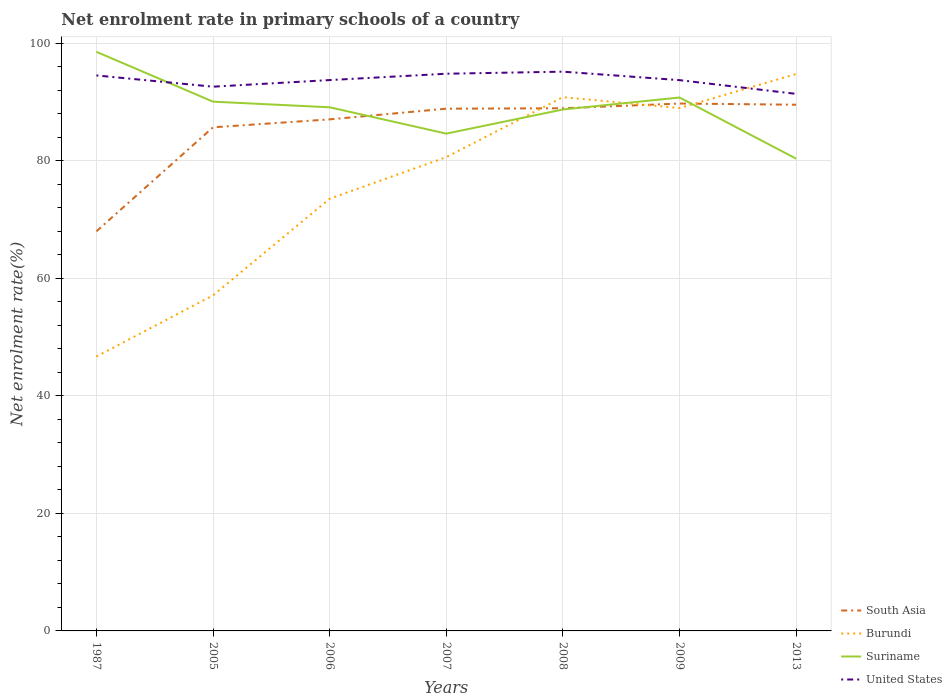Does the line corresponding to Suriname intersect with the line corresponding to Burundi?
Keep it short and to the point. Yes. Across all years, what is the maximum net enrolment rate in primary schools in South Asia?
Provide a short and direct response. 68.01. In which year was the net enrolment rate in primary schools in Burundi maximum?
Give a very brief answer. 1987. What is the total net enrolment rate in primary schools in United States in the graph?
Your answer should be very brief. -1.08. What is the difference between the highest and the second highest net enrolment rate in primary schools in South Asia?
Give a very brief answer. 21.74. What is the difference between the highest and the lowest net enrolment rate in primary schools in Suriname?
Your response must be concise. 4. Are the values on the major ticks of Y-axis written in scientific E-notation?
Your answer should be compact. No. Does the graph contain grids?
Your answer should be compact. Yes. Where does the legend appear in the graph?
Your answer should be very brief. Bottom right. How many legend labels are there?
Provide a short and direct response. 4. What is the title of the graph?
Your answer should be compact. Net enrolment rate in primary schools of a country. What is the label or title of the X-axis?
Offer a terse response. Years. What is the label or title of the Y-axis?
Provide a short and direct response. Net enrolment rate(%). What is the Net enrolment rate(%) of South Asia in 1987?
Ensure brevity in your answer.  68.01. What is the Net enrolment rate(%) in Burundi in 1987?
Provide a succinct answer. 46.7. What is the Net enrolment rate(%) in Suriname in 1987?
Offer a terse response. 98.55. What is the Net enrolment rate(%) in United States in 1987?
Offer a very short reply. 94.53. What is the Net enrolment rate(%) of South Asia in 2005?
Provide a short and direct response. 85.71. What is the Net enrolment rate(%) of Burundi in 2005?
Provide a short and direct response. 57.1. What is the Net enrolment rate(%) in Suriname in 2005?
Provide a short and direct response. 90.07. What is the Net enrolment rate(%) of United States in 2005?
Offer a very short reply. 92.62. What is the Net enrolment rate(%) of South Asia in 2006?
Offer a very short reply. 87.05. What is the Net enrolment rate(%) in Burundi in 2006?
Give a very brief answer. 73.55. What is the Net enrolment rate(%) of Suriname in 2006?
Make the answer very short. 89.11. What is the Net enrolment rate(%) of United States in 2006?
Your response must be concise. 93.74. What is the Net enrolment rate(%) of South Asia in 2007?
Offer a very short reply. 88.87. What is the Net enrolment rate(%) of Burundi in 2007?
Keep it short and to the point. 80.63. What is the Net enrolment rate(%) of Suriname in 2007?
Provide a succinct answer. 84.63. What is the Net enrolment rate(%) of United States in 2007?
Make the answer very short. 94.82. What is the Net enrolment rate(%) of South Asia in 2008?
Your answer should be very brief. 88.95. What is the Net enrolment rate(%) of Burundi in 2008?
Make the answer very short. 90.83. What is the Net enrolment rate(%) of Suriname in 2008?
Offer a very short reply. 88.74. What is the Net enrolment rate(%) in United States in 2008?
Your answer should be very brief. 95.17. What is the Net enrolment rate(%) in South Asia in 2009?
Your answer should be very brief. 89.75. What is the Net enrolment rate(%) in Burundi in 2009?
Your answer should be compact. 88.98. What is the Net enrolment rate(%) in Suriname in 2009?
Give a very brief answer. 90.78. What is the Net enrolment rate(%) in United States in 2009?
Provide a short and direct response. 93.73. What is the Net enrolment rate(%) in South Asia in 2013?
Your response must be concise. 89.55. What is the Net enrolment rate(%) in Burundi in 2013?
Offer a terse response. 94.77. What is the Net enrolment rate(%) of Suriname in 2013?
Offer a terse response. 80.36. What is the Net enrolment rate(%) in United States in 2013?
Provide a short and direct response. 91.39. Across all years, what is the maximum Net enrolment rate(%) in South Asia?
Keep it short and to the point. 89.75. Across all years, what is the maximum Net enrolment rate(%) of Burundi?
Your answer should be very brief. 94.77. Across all years, what is the maximum Net enrolment rate(%) of Suriname?
Your answer should be very brief. 98.55. Across all years, what is the maximum Net enrolment rate(%) of United States?
Give a very brief answer. 95.17. Across all years, what is the minimum Net enrolment rate(%) of South Asia?
Offer a very short reply. 68.01. Across all years, what is the minimum Net enrolment rate(%) in Burundi?
Your answer should be compact. 46.7. Across all years, what is the minimum Net enrolment rate(%) in Suriname?
Your response must be concise. 80.36. Across all years, what is the minimum Net enrolment rate(%) in United States?
Provide a succinct answer. 91.39. What is the total Net enrolment rate(%) of South Asia in the graph?
Provide a succinct answer. 597.88. What is the total Net enrolment rate(%) of Burundi in the graph?
Your answer should be compact. 532.56. What is the total Net enrolment rate(%) in Suriname in the graph?
Provide a short and direct response. 622.24. What is the total Net enrolment rate(%) of United States in the graph?
Your answer should be very brief. 656.01. What is the difference between the Net enrolment rate(%) in South Asia in 1987 and that in 2005?
Provide a succinct answer. -17.7. What is the difference between the Net enrolment rate(%) of Burundi in 1987 and that in 2005?
Your answer should be very brief. -10.4. What is the difference between the Net enrolment rate(%) of Suriname in 1987 and that in 2005?
Keep it short and to the point. 8.48. What is the difference between the Net enrolment rate(%) in United States in 1987 and that in 2005?
Ensure brevity in your answer.  1.91. What is the difference between the Net enrolment rate(%) in South Asia in 1987 and that in 2006?
Ensure brevity in your answer.  -19.05. What is the difference between the Net enrolment rate(%) in Burundi in 1987 and that in 2006?
Your answer should be compact. -26.85. What is the difference between the Net enrolment rate(%) of Suriname in 1987 and that in 2006?
Make the answer very short. 9.44. What is the difference between the Net enrolment rate(%) of United States in 1987 and that in 2006?
Give a very brief answer. 0.79. What is the difference between the Net enrolment rate(%) of South Asia in 1987 and that in 2007?
Provide a succinct answer. -20.87. What is the difference between the Net enrolment rate(%) in Burundi in 1987 and that in 2007?
Your response must be concise. -33.93. What is the difference between the Net enrolment rate(%) in Suriname in 1987 and that in 2007?
Provide a short and direct response. 13.92. What is the difference between the Net enrolment rate(%) of United States in 1987 and that in 2007?
Provide a succinct answer. -0.29. What is the difference between the Net enrolment rate(%) of South Asia in 1987 and that in 2008?
Offer a very short reply. -20.94. What is the difference between the Net enrolment rate(%) of Burundi in 1987 and that in 2008?
Your answer should be very brief. -44.13. What is the difference between the Net enrolment rate(%) of Suriname in 1987 and that in 2008?
Offer a very short reply. 9.82. What is the difference between the Net enrolment rate(%) in United States in 1987 and that in 2008?
Offer a terse response. -0.64. What is the difference between the Net enrolment rate(%) of South Asia in 1987 and that in 2009?
Offer a very short reply. -21.74. What is the difference between the Net enrolment rate(%) of Burundi in 1987 and that in 2009?
Keep it short and to the point. -42.28. What is the difference between the Net enrolment rate(%) in Suriname in 1987 and that in 2009?
Make the answer very short. 7.78. What is the difference between the Net enrolment rate(%) of United States in 1987 and that in 2009?
Your answer should be very brief. 0.8. What is the difference between the Net enrolment rate(%) in South Asia in 1987 and that in 2013?
Provide a succinct answer. -21.54. What is the difference between the Net enrolment rate(%) in Burundi in 1987 and that in 2013?
Provide a short and direct response. -48.08. What is the difference between the Net enrolment rate(%) in Suriname in 1987 and that in 2013?
Offer a terse response. 18.19. What is the difference between the Net enrolment rate(%) of United States in 1987 and that in 2013?
Offer a very short reply. 3.14. What is the difference between the Net enrolment rate(%) in South Asia in 2005 and that in 2006?
Keep it short and to the point. -1.35. What is the difference between the Net enrolment rate(%) of Burundi in 2005 and that in 2006?
Keep it short and to the point. -16.45. What is the difference between the Net enrolment rate(%) of Suriname in 2005 and that in 2006?
Offer a terse response. 0.96. What is the difference between the Net enrolment rate(%) in United States in 2005 and that in 2006?
Your response must be concise. -1.13. What is the difference between the Net enrolment rate(%) in South Asia in 2005 and that in 2007?
Provide a succinct answer. -3.17. What is the difference between the Net enrolment rate(%) in Burundi in 2005 and that in 2007?
Your answer should be very brief. -23.53. What is the difference between the Net enrolment rate(%) of Suriname in 2005 and that in 2007?
Provide a short and direct response. 5.44. What is the difference between the Net enrolment rate(%) of United States in 2005 and that in 2007?
Give a very brief answer. -2.21. What is the difference between the Net enrolment rate(%) in South Asia in 2005 and that in 2008?
Provide a succinct answer. -3.24. What is the difference between the Net enrolment rate(%) in Burundi in 2005 and that in 2008?
Your answer should be compact. -33.73. What is the difference between the Net enrolment rate(%) of Suriname in 2005 and that in 2008?
Keep it short and to the point. 1.33. What is the difference between the Net enrolment rate(%) of United States in 2005 and that in 2008?
Offer a terse response. -2.55. What is the difference between the Net enrolment rate(%) in South Asia in 2005 and that in 2009?
Offer a very short reply. -4.04. What is the difference between the Net enrolment rate(%) in Burundi in 2005 and that in 2009?
Offer a terse response. -31.87. What is the difference between the Net enrolment rate(%) of Suriname in 2005 and that in 2009?
Your response must be concise. -0.71. What is the difference between the Net enrolment rate(%) in United States in 2005 and that in 2009?
Provide a short and direct response. -1.11. What is the difference between the Net enrolment rate(%) in South Asia in 2005 and that in 2013?
Give a very brief answer. -3.84. What is the difference between the Net enrolment rate(%) in Burundi in 2005 and that in 2013?
Your answer should be very brief. -37.67. What is the difference between the Net enrolment rate(%) of Suriname in 2005 and that in 2013?
Give a very brief answer. 9.71. What is the difference between the Net enrolment rate(%) of United States in 2005 and that in 2013?
Offer a terse response. 1.23. What is the difference between the Net enrolment rate(%) in South Asia in 2006 and that in 2007?
Ensure brevity in your answer.  -1.82. What is the difference between the Net enrolment rate(%) in Burundi in 2006 and that in 2007?
Give a very brief answer. -7.08. What is the difference between the Net enrolment rate(%) in Suriname in 2006 and that in 2007?
Provide a short and direct response. 4.48. What is the difference between the Net enrolment rate(%) in United States in 2006 and that in 2007?
Provide a succinct answer. -1.08. What is the difference between the Net enrolment rate(%) in South Asia in 2006 and that in 2008?
Your answer should be very brief. -1.89. What is the difference between the Net enrolment rate(%) of Burundi in 2006 and that in 2008?
Give a very brief answer. -17.28. What is the difference between the Net enrolment rate(%) of Suriname in 2006 and that in 2008?
Make the answer very short. 0.37. What is the difference between the Net enrolment rate(%) in United States in 2006 and that in 2008?
Make the answer very short. -1.43. What is the difference between the Net enrolment rate(%) of South Asia in 2006 and that in 2009?
Keep it short and to the point. -2.7. What is the difference between the Net enrolment rate(%) of Burundi in 2006 and that in 2009?
Your response must be concise. -15.43. What is the difference between the Net enrolment rate(%) in Suriname in 2006 and that in 2009?
Your response must be concise. -1.67. What is the difference between the Net enrolment rate(%) of United States in 2006 and that in 2009?
Ensure brevity in your answer.  0.01. What is the difference between the Net enrolment rate(%) in South Asia in 2006 and that in 2013?
Make the answer very short. -2.49. What is the difference between the Net enrolment rate(%) in Burundi in 2006 and that in 2013?
Ensure brevity in your answer.  -21.22. What is the difference between the Net enrolment rate(%) of Suriname in 2006 and that in 2013?
Offer a very short reply. 8.75. What is the difference between the Net enrolment rate(%) of United States in 2006 and that in 2013?
Offer a very short reply. 2.35. What is the difference between the Net enrolment rate(%) in South Asia in 2007 and that in 2008?
Provide a short and direct response. -0.07. What is the difference between the Net enrolment rate(%) in Burundi in 2007 and that in 2008?
Ensure brevity in your answer.  -10.2. What is the difference between the Net enrolment rate(%) of Suriname in 2007 and that in 2008?
Ensure brevity in your answer.  -4.11. What is the difference between the Net enrolment rate(%) of United States in 2007 and that in 2008?
Provide a short and direct response. -0.35. What is the difference between the Net enrolment rate(%) of South Asia in 2007 and that in 2009?
Make the answer very short. -0.88. What is the difference between the Net enrolment rate(%) in Burundi in 2007 and that in 2009?
Offer a terse response. -8.35. What is the difference between the Net enrolment rate(%) of Suriname in 2007 and that in 2009?
Offer a very short reply. -6.15. What is the difference between the Net enrolment rate(%) of United States in 2007 and that in 2009?
Keep it short and to the point. 1.09. What is the difference between the Net enrolment rate(%) in South Asia in 2007 and that in 2013?
Keep it short and to the point. -0.68. What is the difference between the Net enrolment rate(%) of Burundi in 2007 and that in 2013?
Your answer should be compact. -14.15. What is the difference between the Net enrolment rate(%) in Suriname in 2007 and that in 2013?
Offer a very short reply. 4.27. What is the difference between the Net enrolment rate(%) in United States in 2007 and that in 2013?
Your answer should be compact. 3.43. What is the difference between the Net enrolment rate(%) in South Asia in 2008 and that in 2009?
Your answer should be very brief. -0.8. What is the difference between the Net enrolment rate(%) in Burundi in 2008 and that in 2009?
Offer a terse response. 1.85. What is the difference between the Net enrolment rate(%) in Suriname in 2008 and that in 2009?
Your answer should be very brief. -2.04. What is the difference between the Net enrolment rate(%) in United States in 2008 and that in 2009?
Offer a terse response. 1.44. What is the difference between the Net enrolment rate(%) of South Asia in 2008 and that in 2013?
Make the answer very short. -0.6. What is the difference between the Net enrolment rate(%) in Burundi in 2008 and that in 2013?
Offer a terse response. -3.94. What is the difference between the Net enrolment rate(%) of Suriname in 2008 and that in 2013?
Provide a short and direct response. 8.38. What is the difference between the Net enrolment rate(%) of United States in 2008 and that in 2013?
Offer a very short reply. 3.78. What is the difference between the Net enrolment rate(%) in South Asia in 2009 and that in 2013?
Keep it short and to the point. 0.2. What is the difference between the Net enrolment rate(%) of Burundi in 2009 and that in 2013?
Give a very brief answer. -5.8. What is the difference between the Net enrolment rate(%) in Suriname in 2009 and that in 2013?
Your answer should be very brief. 10.42. What is the difference between the Net enrolment rate(%) of United States in 2009 and that in 2013?
Give a very brief answer. 2.34. What is the difference between the Net enrolment rate(%) of South Asia in 1987 and the Net enrolment rate(%) of Burundi in 2005?
Your answer should be very brief. 10.9. What is the difference between the Net enrolment rate(%) in South Asia in 1987 and the Net enrolment rate(%) in Suriname in 2005?
Give a very brief answer. -22.07. What is the difference between the Net enrolment rate(%) in South Asia in 1987 and the Net enrolment rate(%) in United States in 2005?
Your answer should be very brief. -24.61. What is the difference between the Net enrolment rate(%) in Burundi in 1987 and the Net enrolment rate(%) in Suriname in 2005?
Ensure brevity in your answer.  -43.37. What is the difference between the Net enrolment rate(%) of Burundi in 1987 and the Net enrolment rate(%) of United States in 2005?
Offer a very short reply. -45.92. What is the difference between the Net enrolment rate(%) in Suriname in 1987 and the Net enrolment rate(%) in United States in 2005?
Ensure brevity in your answer.  5.93. What is the difference between the Net enrolment rate(%) in South Asia in 1987 and the Net enrolment rate(%) in Burundi in 2006?
Give a very brief answer. -5.54. What is the difference between the Net enrolment rate(%) in South Asia in 1987 and the Net enrolment rate(%) in Suriname in 2006?
Provide a succinct answer. -21.1. What is the difference between the Net enrolment rate(%) of South Asia in 1987 and the Net enrolment rate(%) of United States in 2006?
Your answer should be compact. -25.74. What is the difference between the Net enrolment rate(%) in Burundi in 1987 and the Net enrolment rate(%) in Suriname in 2006?
Your response must be concise. -42.41. What is the difference between the Net enrolment rate(%) in Burundi in 1987 and the Net enrolment rate(%) in United States in 2006?
Offer a very short reply. -47.04. What is the difference between the Net enrolment rate(%) of Suriname in 1987 and the Net enrolment rate(%) of United States in 2006?
Keep it short and to the point. 4.81. What is the difference between the Net enrolment rate(%) of South Asia in 1987 and the Net enrolment rate(%) of Burundi in 2007?
Make the answer very short. -12.62. What is the difference between the Net enrolment rate(%) in South Asia in 1987 and the Net enrolment rate(%) in Suriname in 2007?
Your response must be concise. -16.63. What is the difference between the Net enrolment rate(%) of South Asia in 1987 and the Net enrolment rate(%) of United States in 2007?
Offer a terse response. -26.82. What is the difference between the Net enrolment rate(%) of Burundi in 1987 and the Net enrolment rate(%) of Suriname in 2007?
Your answer should be very brief. -37.93. What is the difference between the Net enrolment rate(%) of Burundi in 1987 and the Net enrolment rate(%) of United States in 2007?
Your response must be concise. -48.12. What is the difference between the Net enrolment rate(%) in Suriname in 1987 and the Net enrolment rate(%) in United States in 2007?
Offer a terse response. 3.73. What is the difference between the Net enrolment rate(%) in South Asia in 1987 and the Net enrolment rate(%) in Burundi in 2008?
Offer a terse response. -22.83. What is the difference between the Net enrolment rate(%) of South Asia in 1987 and the Net enrolment rate(%) of Suriname in 2008?
Make the answer very short. -20.73. What is the difference between the Net enrolment rate(%) of South Asia in 1987 and the Net enrolment rate(%) of United States in 2008?
Offer a terse response. -27.17. What is the difference between the Net enrolment rate(%) of Burundi in 1987 and the Net enrolment rate(%) of Suriname in 2008?
Provide a short and direct response. -42.04. What is the difference between the Net enrolment rate(%) of Burundi in 1987 and the Net enrolment rate(%) of United States in 2008?
Give a very brief answer. -48.47. What is the difference between the Net enrolment rate(%) of Suriname in 1987 and the Net enrolment rate(%) of United States in 2008?
Offer a very short reply. 3.38. What is the difference between the Net enrolment rate(%) of South Asia in 1987 and the Net enrolment rate(%) of Burundi in 2009?
Your answer should be compact. -20.97. What is the difference between the Net enrolment rate(%) in South Asia in 1987 and the Net enrolment rate(%) in Suriname in 2009?
Give a very brief answer. -22.77. What is the difference between the Net enrolment rate(%) of South Asia in 1987 and the Net enrolment rate(%) of United States in 2009?
Your response must be concise. -25.73. What is the difference between the Net enrolment rate(%) of Burundi in 1987 and the Net enrolment rate(%) of Suriname in 2009?
Your answer should be very brief. -44.08. What is the difference between the Net enrolment rate(%) of Burundi in 1987 and the Net enrolment rate(%) of United States in 2009?
Offer a very short reply. -47.03. What is the difference between the Net enrolment rate(%) of Suriname in 1987 and the Net enrolment rate(%) of United States in 2009?
Your response must be concise. 4.82. What is the difference between the Net enrolment rate(%) of South Asia in 1987 and the Net enrolment rate(%) of Burundi in 2013?
Provide a short and direct response. -26.77. What is the difference between the Net enrolment rate(%) of South Asia in 1987 and the Net enrolment rate(%) of Suriname in 2013?
Your response must be concise. -12.36. What is the difference between the Net enrolment rate(%) in South Asia in 1987 and the Net enrolment rate(%) in United States in 2013?
Provide a short and direct response. -23.39. What is the difference between the Net enrolment rate(%) of Burundi in 1987 and the Net enrolment rate(%) of Suriname in 2013?
Offer a terse response. -33.66. What is the difference between the Net enrolment rate(%) in Burundi in 1987 and the Net enrolment rate(%) in United States in 2013?
Your answer should be compact. -44.69. What is the difference between the Net enrolment rate(%) in Suriname in 1987 and the Net enrolment rate(%) in United States in 2013?
Ensure brevity in your answer.  7.16. What is the difference between the Net enrolment rate(%) in South Asia in 2005 and the Net enrolment rate(%) in Burundi in 2006?
Your answer should be compact. 12.16. What is the difference between the Net enrolment rate(%) of South Asia in 2005 and the Net enrolment rate(%) of Suriname in 2006?
Keep it short and to the point. -3.4. What is the difference between the Net enrolment rate(%) in South Asia in 2005 and the Net enrolment rate(%) in United States in 2006?
Offer a terse response. -8.04. What is the difference between the Net enrolment rate(%) in Burundi in 2005 and the Net enrolment rate(%) in Suriname in 2006?
Your response must be concise. -32.01. What is the difference between the Net enrolment rate(%) of Burundi in 2005 and the Net enrolment rate(%) of United States in 2006?
Your answer should be very brief. -36.64. What is the difference between the Net enrolment rate(%) of Suriname in 2005 and the Net enrolment rate(%) of United States in 2006?
Keep it short and to the point. -3.67. What is the difference between the Net enrolment rate(%) in South Asia in 2005 and the Net enrolment rate(%) in Burundi in 2007?
Keep it short and to the point. 5.08. What is the difference between the Net enrolment rate(%) in South Asia in 2005 and the Net enrolment rate(%) in Suriname in 2007?
Give a very brief answer. 1.07. What is the difference between the Net enrolment rate(%) in South Asia in 2005 and the Net enrolment rate(%) in United States in 2007?
Offer a terse response. -9.12. What is the difference between the Net enrolment rate(%) of Burundi in 2005 and the Net enrolment rate(%) of Suriname in 2007?
Make the answer very short. -27.53. What is the difference between the Net enrolment rate(%) in Burundi in 2005 and the Net enrolment rate(%) in United States in 2007?
Provide a succinct answer. -37.72. What is the difference between the Net enrolment rate(%) of Suriname in 2005 and the Net enrolment rate(%) of United States in 2007?
Your response must be concise. -4.75. What is the difference between the Net enrolment rate(%) in South Asia in 2005 and the Net enrolment rate(%) in Burundi in 2008?
Give a very brief answer. -5.13. What is the difference between the Net enrolment rate(%) of South Asia in 2005 and the Net enrolment rate(%) of Suriname in 2008?
Your response must be concise. -3.03. What is the difference between the Net enrolment rate(%) of South Asia in 2005 and the Net enrolment rate(%) of United States in 2008?
Your answer should be compact. -9.47. What is the difference between the Net enrolment rate(%) of Burundi in 2005 and the Net enrolment rate(%) of Suriname in 2008?
Give a very brief answer. -31.63. What is the difference between the Net enrolment rate(%) of Burundi in 2005 and the Net enrolment rate(%) of United States in 2008?
Offer a terse response. -38.07. What is the difference between the Net enrolment rate(%) of Suriname in 2005 and the Net enrolment rate(%) of United States in 2008?
Offer a very short reply. -5.1. What is the difference between the Net enrolment rate(%) of South Asia in 2005 and the Net enrolment rate(%) of Burundi in 2009?
Your response must be concise. -3.27. What is the difference between the Net enrolment rate(%) of South Asia in 2005 and the Net enrolment rate(%) of Suriname in 2009?
Make the answer very short. -5.07. What is the difference between the Net enrolment rate(%) in South Asia in 2005 and the Net enrolment rate(%) in United States in 2009?
Provide a succinct answer. -8.03. What is the difference between the Net enrolment rate(%) of Burundi in 2005 and the Net enrolment rate(%) of Suriname in 2009?
Keep it short and to the point. -33.67. What is the difference between the Net enrolment rate(%) of Burundi in 2005 and the Net enrolment rate(%) of United States in 2009?
Your answer should be very brief. -36.63. What is the difference between the Net enrolment rate(%) of Suriname in 2005 and the Net enrolment rate(%) of United States in 2009?
Your answer should be very brief. -3.66. What is the difference between the Net enrolment rate(%) of South Asia in 2005 and the Net enrolment rate(%) of Burundi in 2013?
Offer a terse response. -9.07. What is the difference between the Net enrolment rate(%) in South Asia in 2005 and the Net enrolment rate(%) in Suriname in 2013?
Offer a very short reply. 5.34. What is the difference between the Net enrolment rate(%) in South Asia in 2005 and the Net enrolment rate(%) in United States in 2013?
Your response must be concise. -5.69. What is the difference between the Net enrolment rate(%) in Burundi in 2005 and the Net enrolment rate(%) in Suriname in 2013?
Provide a short and direct response. -23.26. What is the difference between the Net enrolment rate(%) of Burundi in 2005 and the Net enrolment rate(%) of United States in 2013?
Give a very brief answer. -34.29. What is the difference between the Net enrolment rate(%) in Suriname in 2005 and the Net enrolment rate(%) in United States in 2013?
Make the answer very short. -1.32. What is the difference between the Net enrolment rate(%) in South Asia in 2006 and the Net enrolment rate(%) in Burundi in 2007?
Ensure brevity in your answer.  6.43. What is the difference between the Net enrolment rate(%) in South Asia in 2006 and the Net enrolment rate(%) in Suriname in 2007?
Your answer should be compact. 2.42. What is the difference between the Net enrolment rate(%) in South Asia in 2006 and the Net enrolment rate(%) in United States in 2007?
Provide a short and direct response. -7.77. What is the difference between the Net enrolment rate(%) of Burundi in 2006 and the Net enrolment rate(%) of Suriname in 2007?
Your answer should be very brief. -11.08. What is the difference between the Net enrolment rate(%) of Burundi in 2006 and the Net enrolment rate(%) of United States in 2007?
Provide a short and direct response. -21.27. What is the difference between the Net enrolment rate(%) of Suriname in 2006 and the Net enrolment rate(%) of United States in 2007?
Provide a short and direct response. -5.71. What is the difference between the Net enrolment rate(%) in South Asia in 2006 and the Net enrolment rate(%) in Burundi in 2008?
Offer a very short reply. -3.78. What is the difference between the Net enrolment rate(%) of South Asia in 2006 and the Net enrolment rate(%) of Suriname in 2008?
Offer a very short reply. -1.68. What is the difference between the Net enrolment rate(%) of South Asia in 2006 and the Net enrolment rate(%) of United States in 2008?
Provide a short and direct response. -8.12. What is the difference between the Net enrolment rate(%) of Burundi in 2006 and the Net enrolment rate(%) of Suriname in 2008?
Offer a terse response. -15.19. What is the difference between the Net enrolment rate(%) in Burundi in 2006 and the Net enrolment rate(%) in United States in 2008?
Make the answer very short. -21.62. What is the difference between the Net enrolment rate(%) of Suriname in 2006 and the Net enrolment rate(%) of United States in 2008?
Offer a very short reply. -6.06. What is the difference between the Net enrolment rate(%) of South Asia in 2006 and the Net enrolment rate(%) of Burundi in 2009?
Your answer should be compact. -1.92. What is the difference between the Net enrolment rate(%) of South Asia in 2006 and the Net enrolment rate(%) of Suriname in 2009?
Your answer should be very brief. -3.72. What is the difference between the Net enrolment rate(%) in South Asia in 2006 and the Net enrolment rate(%) in United States in 2009?
Keep it short and to the point. -6.68. What is the difference between the Net enrolment rate(%) in Burundi in 2006 and the Net enrolment rate(%) in Suriname in 2009?
Provide a succinct answer. -17.23. What is the difference between the Net enrolment rate(%) of Burundi in 2006 and the Net enrolment rate(%) of United States in 2009?
Keep it short and to the point. -20.18. What is the difference between the Net enrolment rate(%) in Suriname in 2006 and the Net enrolment rate(%) in United States in 2009?
Give a very brief answer. -4.62. What is the difference between the Net enrolment rate(%) in South Asia in 2006 and the Net enrolment rate(%) in Burundi in 2013?
Ensure brevity in your answer.  -7.72. What is the difference between the Net enrolment rate(%) in South Asia in 2006 and the Net enrolment rate(%) in Suriname in 2013?
Your answer should be compact. 6.69. What is the difference between the Net enrolment rate(%) in South Asia in 2006 and the Net enrolment rate(%) in United States in 2013?
Offer a terse response. -4.34. What is the difference between the Net enrolment rate(%) of Burundi in 2006 and the Net enrolment rate(%) of Suriname in 2013?
Offer a very short reply. -6.81. What is the difference between the Net enrolment rate(%) of Burundi in 2006 and the Net enrolment rate(%) of United States in 2013?
Your response must be concise. -17.84. What is the difference between the Net enrolment rate(%) of Suriname in 2006 and the Net enrolment rate(%) of United States in 2013?
Keep it short and to the point. -2.28. What is the difference between the Net enrolment rate(%) in South Asia in 2007 and the Net enrolment rate(%) in Burundi in 2008?
Your answer should be very brief. -1.96. What is the difference between the Net enrolment rate(%) in South Asia in 2007 and the Net enrolment rate(%) in Suriname in 2008?
Keep it short and to the point. 0.14. What is the difference between the Net enrolment rate(%) of South Asia in 2007 and the Net enrolment rate(%) of United States in 2008?
Ensure brevity in your answer.  -6.3. What is the difference between the Net enrolment rate(%) in Burundi in 2007 and the Net enrolment rate(%) in Suriname in 2008?
Provide a succinct answer. -8.11. What is the difference between the Net enrolment rate(%) of Burundi in 2007 and the Net enrolment rate(%) of United States in 2008?
Offer a very short reply. -14.54. What is the difference between the Net enrolment rate(%) of Suriname in 2007 and the Net enrolment rate(%) of United States in 2008?
Give a very brief answer. -10.54. What is the difference between the Net enrolment rate(%) of South Asia in 2007 and the Net enrolment rate(%) of Burundi in 2009?
Give a very brief answer. -0.1. What is the difference between the Net enrolment rate(%) in South Asia in 2007 and the Net enrolment rate(%) in Suriname in 2009?
Provide a short and direct response. -1.9. What is the difference between the Net enrolment rate(%) of South Asia in 2007 and the Net enrolment rate(%) of United States in 2009?
Keep it short and to the point. -4.86. What is the difference between the Net enrolment rate(%) in Burundi in 2007 and the Net enrolment rate(%) in Suriname in 2009?
Ensure brevity in your answer.  -10.15. What is the difference between the Net enrolment rate(%) of Burundi in 2007 and the Net enrolment rate(%) of United States in 2009?
Keep it short and to the point. -13.1. What is the difference between the Net enrolment rate(%) in Suriname in 2007 and the Net enrolment rate(%) in United States in 2009?
Keep it short and to the point. -9.1. What is the difference between the Net enrolment rate(%) in South Asia in 2007 and the Net enrolment rate(%) in Burundi in 2013?
Your answer should be compact. -5.9. What is the difference between the Net enrolment rate(%) of South Asia in 2007 and the Net enrolment rate(%) of Suriname in 2013?
Offer a very short reply. 8.51. What is the difference between the Net enrolment rate(%) in South Asia in 2007 and the Net enrolment rate(%) in United States in 2013?
Provide a short and direct response. -2.52. What is the difference between the Net enrolment rate(%) in Burundi in 2007 and the Net enrolment rate(%) in Suriname in 2013?
Keep it short and to the point. 0.27. What is the difference between the Net enrolment rate(%) of Burundi in 2007 and the Net enrolment rate(%) of United States in 2013?
Your answer should be very brief. -10.76. What is the difference between the Net enrolment rate(%) in Suriname in 2007 and the Net enrolment rate(%) in United States in 2013?
Provide a short and direct response. -6.76. What is the difference between the Net enrolment rate(%) of South Asia in 2008 and the Net enrolment rate(%) of Burundi in 2009?
Make the answer very short. -0.03. What is the difference between the Net enrolment rate(%) in South Asia in 2008 and the Net enrolment rate(%) in Suriname in 2009?
Offer a very short reply. -1.83. What is the difference between the Net enrolment rate(%) of South Asia in 2008 and the Net enrolment rate(%) of United States in 2009?
Keep it short and to the point. -4.79. What is the difference between the Net enrolment rate(%) in Burundi in 2008 and the Net enrolment rate(%) in Suriname in 2009?
Keep it short and to the point. 0.06. What is the difference between the Net enrolment rate(%) in Burundi in 2008 and the Net enrolment rate(%) in United States in 2009?
Keep it short and to the point. -2.9. What is the difference between the Net enrolment rate(%) in Suriname in 2008 and the Net enrolment rate(%) in United States in 2009?
Offer a terse response. -5. What is the difference between the Net enrolment rate(%) in South Asia in 2008 and the Net enrolment rate(%) in Burundi in 2013?
Keep it short and to the point. -5.83. What is the difference between the Net enrolment rate(%) in South Asia in 2008 and the Net enrolment rate(%) in Suriname in 2013?
Offer a very short reply. 8.59. What is the difference between the Net enrolment rate(%) in South Asia in 2008 and the Net enrolment rate(%) in United States in 2013?
Provide a succinct answer. -2.45. What is the difference between the Net enrolment rate(%) in Burundi in 2008 and the Net enrolment rate(%) in Suriname in 2013?
Provide a short and direct response. 10.47. What is the difference between the Net enrolment rate(%) in Burundi in 2008 and the Net enrolment rate(%) in United States in 2013?
Make the answer very short. -0.56. What is the difference between the Net enrolment rate(%) of Suriname in 2008 and the Net enrolment rate(%) of United States in 2013?
Your response must be concise. -2.66. What is the difference between the Net enrolment rate(%) in South Asia in 2009 and the Net enrolment rate(%) in Burundi in 2013?
Ensure brevity in your answer.  -5.02. What is the difference between the Net enrolment rate(%) of South Asia in 2009 and the Net enrolment rate(%) of Suriname in 2013?
Give a very brief answer. 9.39. What is the difference between the Net enrolment rate(%) of South Asia in 2009 and the Net enrolment rate(%) of United States in 2013?
Your answer should be very brief. -1.64. What is the difference between the Net enrolment rate(%) of Burundi in 2009 and the Net enrolment rate(%) of Suriname in 2013?
Your answer should be compact. 8.62. What is the difference between the Net enrolment rate(%) in Burundi in 2009 and the Net enrolment rate(%) in United States in 2013?
Your answer should be compact. -2.42. What is the difference between the Net enrolment rate(%) in Suriname in 2009 and the Net enrolment rate(%) in United States in 2013?
Your answer should be compact. -0.62. What is the average Net enrolment rate(%) of South Asia per year?
Provide a succinct answer. 85.41. What is the average Net enrolment rate(%) in Burundi per year?
Offer a terse response. 76.08. What is the average Net enrolment rate(%) in Suriname per year?
Offer a terse response. 88.89. What is the average Net enrolment rate(%) in United States per year?
Provide a short and direct response. 93.72. In the year 1987, what is the difference between the Net enrolment rate(%) in South Asia and Net enrolment rate(%) in Burundi?
Your response must be concise. 21.31. In the year 1987, what is the difference between the Net enrolment rate(%) in South Asia and Net enrolment rate(%) in Suriname?
Make the answer very short. -30.55. In the year 1987, what is the difference between the Net enrolment rate(%) of South Asia and Net enrolment rate(%) of United States?
Provide a short and direct response. -26.53. In the year 1987, what is the difference between the Net enrolment rate(%) of Burundi and Net enrolment rate(%) of Suriname?
Provide a short and direct response. -51.85. In the year 1987, what is the difference between the Net enrolment rate(%) in Burundi and Net enrolment rate(%) in United States?
Provide a succinct answer. -47.83. In the year 1987, what is the difference between the Net enrolment rate(%) of Suriname and Net enrolment rate(%) of United States?
Ensure brevity in your answer.  4.02. In the year 2005, what is the difference between the Net enrolment rate(%) of South Asia and Net enrolment rate(%) of Burundi?
Make the answer very short. 28.6. In the year 2005, what is the difference between the Net enrolment rate(%) in South Asia and Net enrolment rate(%) in Suriname?
Keep it short and to the point. -4.37. In the year 2005, what is the difference between the Net enrolment rate(%) of South Asia and Net enrolment rate(%) of United States?
Your answer should be compact. -6.91. In the year 2005, what is the difference between the Net enrolment rate(%) of Burundi and Net enrolment rate(%) of Suriname?
Provide a succinct answer. -32.97. In the year 2005, what is the difference between the Net enrolment rate(%) of Burundi and Net enrolment rate(%) of United States?
Give a very brief answer. -35.52. In the year 2005, what is the difference between the Net enrolment rate(%) of Suriname and Net enrolment rate(%) of United States?
Your response must be concise. -2.55. In the year 2006, what is the difference between the Net enrolment rate(%) of South Asia and Net enrolment rate(%) of Burundi?
Give a very brief answer. 13.5. In the year 2006, what is the difference between the Net enrolment rate(%) of South Asia and Net enrolment rate(%) of Suriname?
Your answer should be very brief. -2.06. In the year 2006, what is the difference between the Net enrolment rate(%) in South Asia and Net enrolment rate(%) in United States?
Provide a succinct answer. -6.69. In the year 2006, what is the difference between the Net enrolment rate(%) in Burundi and Net enrolment rate(%) in Suriname?
Your answer should be compact. -15.56. In the year 2006, what is the difference between the Net enrolment rate(%) of Burundi and Net enrolment rate(%) of United States?
Give a very brief answer. -20.19. In the year 2006, what is the difference between the Net enrolment rate(%) of Suriname and Net enrolment rate(%) of United States?
Ensure brevity in your answer.  -4.63. In the year 2007, what is the difference between the Net enrolment rate(%) in South Asia and Net enrolment rate(%) in Burundi?
Your answer should be very brief. 8.24. In the year 2007, what is the difference between the Net enrolment rate(%) of South Asia and Net enrolment rate(%) of Suriname?
Offer a terse response. 4.24. In the year 2007, what is the difference between the Net enrolment rate(%) in South Asia and Net enrolment rate(%) in United States?
Keep it short and to the point. -5.95. In the year 2007, what is the difference between the Net enrolment rate(%) of Burundi and Net enrolment rate(%) of Suriname?
Ensure brevity in your answer.  -4. In the year 2007, what is the difference between the Net enrolment rate(%) in Burundi and Net enrolment rate(%) in United States?
Give a very brief answer. -14.19. In the year 2007, what is the difference between the Net enrolment rate(%) of Suriname and Net enrolment rate(%) of United States?
Give a very brief answer. -10.19. In the year 2008, what is the difference between the Net enrolment rate(%) in South Asia and Net enrolment rate(%) in Burundi?
Your response must be concise. -1.89. In the year 2008, what is the difference between the Net enrolment rate(%) of South Asia and Net enrolment rate(%) of Suriname?
Offer a very short reply. 0.21. In the year 2008, what is the difference between the Net enrolment rate(%) in South Asia and Net enrolment rate(%) in United States?
Offer a terse response. -6.23. In the year 2008, what is the difference between the Net enrolment rate(%) in Burundi and Net enrolment rate(%) in Suriname?
Your response must be concise. 2.1. In the year 2008, what is the difference between the Net enrolment rate(%) of Burundi and Net enrolment rate(%) of United States?
Provide a succinct answer. -4.34. In the year 2008, what is the difference between the Net enrolment rate(%) in Suriname and Net enrolment rate(%) in United States?
Offer a terse response. -6.44. In the year 2009, what is the difference between the Net enrolment rate(%) in South Asia and Net enrolment rate(%) in Burundi?
Keep it short and to the point. 0.77. In the year 2009, what is the difference between the Net enrolment rate(%) of South Asia and Net enrolment rate(%) of Suriname?
Your answer should be compact. -1.03. In the year 2009, what is the difference between the Net enrolment rate(%) of South Asia and Net enrolment rate(%) of United States?
Your answer should be very brief. -3.98. In the year 2009, what is the difference between the Net enrolment rate(%) of Burundi and Net enrolment rate(%) of Suriname?
Ensure brevity in your answer.  -1.8. In the year 2009, what is the difference between the Net enrolment rate(%) of Burundi and Net enrolment rate(%) of United States?
Ensure brevity in your answer.  -4.75. In the year 2009, what is the difference between the Net enrolment rate(%) in Suriname and Net enrolment rate(%) in United States?
Ensure brevity in your answer.  -2.96. In the year 2013, what is the difference between the Net enrolment rate(%) of South Asia and Net enrolment rate(%) of Burundi?
Make the answer very short. -5.23. In the year 2013, what is the difference between the Net enrolment rate(%) of South Asia and Net enrolment rate(%) of Suriname?
Make the answer very short. 9.19. In the year 2013, what is the difference between the Net enrolment rate(%) of South Asia and Net enrolment rate(%) of United States?
Ensure brevity in your answer.  -1.84. In the year 2013, what is the difference between the Net enrolment rate(%) in Burundi and Net enrolment rate(%) in Suriname?
Provide a short and direct response. 14.41. In the year 2013, what is the difference between the Net enrolment rate(%) in Burundi and Net enrolment rate(%) in United States?
Your response must be concise. 3.38. In the year 2013, what is the difference between the Net enrolment rate(%) of Suriname and Net enrolment rate(%) of United States?
Provide a succinct answer. -11.03. What is the ratio of the Net enrolment rate(%) in South Asia in 1987 to that in 2005?
Offer a terse response. 0.79. What is the ratio of the Net enrolment rate(%) in Burundi in 1987 to that in 2005?
Provide a succinct answer. 0.82. What is the ratio of the Net enrolment rate(%) of Suriname in 1987 to that in 2005?
Offer a terse response. 1.09. What is the ratio of the Net enrolment rate(%) of United States in 1987 to that in 2005?
Ensure brevity in your answer.  1.02. What is the ratio of the Net enrolment rate(%) of South Asia in 1987 to that in 2006?
Your response must be concise. 0.78. What is the ratio of the Net enrolment rate(%) of Burundi in 1987 to that in 2006?
Your response must be concise. 0.63. What is the ratio of the Net enrolment rate(%) of Suriname in 1987 to that in 2006?
Make the answer very short. 1.11. What is the ratio of the Net enrolment rate(%) of United States in 1987 to that in 2006?
Provide a succinct answer. 1.01. What is the ratio of the Net enrolment rate(%) in South Asia in 1987 to that in 2007?
Make the answer very short. 0.77. What is the ratio of the Net enrolment rate(%) in Burundi in 1987 to that in 2007?
Your response must be concise. 0.58. What is the ratio of the Net enrolment rate(%) of Suriname in 1987 to that in 2007?
Offer a terse response. 1.16. What is the ratio of the Net enrolment rate(%) in United States in 1987 to that in 2007?
Provide a short and direct response. 1. What is the ratio of the Net enrolment rate(%) in South Asia in 1987 to that in 2008?
Your answer should be compact. 0.76. What is the ratio of the Net enrolment rate(%) of Burundi in 1987 to that in 2008?
Make the answer very short. 0.51. What is the ratio of the Net enrolment rate(%) in Suriname in 1987 to that in 2008?
Make the answer very short. 1.11. What is the ratio of the Net enrolment rate(%) of South Asia in 1987 to that in 2009?
Your answer should be very brief. 0.76. What is the ratio of the Net enrolment rate(%) of Burundi in 1987 to that in 2009?
Offer a very short reply. 0.52. What is the ratio of the Net enrolment rate(%) in Suriname in 1987 to that in 2009?
Your answer should be compact. 1.09. What is the ratio of the Net enrolment rate(%) in United States in 1987 to that in 2009?
Keep it short and to the point. 1.01. What is the ratio of the Net enrolment rate(%) in South Asia in 1987 to that in 2013?
Ensure brevity in your answer.  0.76. What is the ratio of the Net enrolment rate(%) of Burundi in 1987 to that in 2013?
Ensure brevity in your answer.  0.49. What is the ratio of the Net enrolment rate(%) in Suriname in 1987 to that in 2013?
Give a very brief answer. 1.23. What is the ratio of the Net enrolment rate(%) in United States in 1987 to that in 2013?
Provide a short and direct response. 1.03. What is the ratio of the Net enrolment rate(%) in South Asia in 2005 to that in 2006?
Offer a terse response. 0.98. What is the ratio of the Net enrolment rate(%) of Burundi in 2005 to that in 2006?
Your response must be concise. 0.78. What is the ratio of the Net enrolment rate(%) of Suriname in 2005 to that in 2006?
Offer a terse response. 1.01. What is the ratio of the Net enrolment rate(%) in United States in 2005 to that in 2006?
Ensure brevity in your answer.  0.99. What is the ratio of the Net enrolment rate(%) of South Asia in 2005 to that in 2007?
Give a very brief answer. 0.96. What is the ratio of the Net enrolment rate(%) in Burundi in 2005 to that in 2007?
Your answer should be very brief. 0.71. What is the ratio of the Net enrolment rate(%) of Suriname in 2005 to that in 2007?
Offer a terse response. 1.06. What is the ratio of the Net enrolment rate(%) of United States in 2005 to that in 2007?
Give a very brief answer. 0.98. What is the ratio of the Net enrolment rate(%) of South Asia in 2005 to that in 2008?
Offer a very short reply. 0.96. What is the ratio of the Net enrolment rate(%) in Burundi in 2005 to that in 2008?
Give a very brief answer. 0.63. What is the ratio of the Net enrolment rate(%) in Suriname in 2005 to that in 2008?
Your answer should be very brief. 1.01. What is the ratio of the Net enrolment rate(%) of United States in 2005 to that in 2008?
Make the answer very short. 0.97. What is the ratio of the Net enrolment rate(%) of South Asia in 2005 to that in 2009?
Provide a succinct answer. 0.95. What is the ratio of the Net enrolment rate(%) in Burundi in 2005 to that in 2009?
Give a very brief answer. 0.64. What is the ratio of the Net enrolment rate(%) in Suriname in 2005 to that in 2009?
Provide a short and direct response. 0.99. What is the ratio of the Net enrolment rate(%) in United States in 2005 to that in 2009?
Give a very brief answer. 0.99. What is the ratio of the Net enrolment rate(%) in South Asia in 2005 to that in 2013?
Offer a terse response. 0.96. What is the ratio of the Net enrolment rate(%) of Burundi in 2005 to that in 2013?
Your response must be concise. 0.6. What is the ratio of the Net enrolment rate(%) of Suriname in 2005 to that in 2013?
Provide a succinct answer. 1.12. What is the ratio of the Net enrolment rate(%) of United States in 2005 to that in 2013?
Provide a short and direct response. 1.01. What is the ratio of the Net enrolment rate(%) of South Asia in 2006 to that in 2007?
Offer a very short reply. 0.98. What is the ratio of the Net enrolment rate(%) in Burundi in 2006 to that in 2007?
Make the answer very short. 0.91. What is the ratio of the Net enrolment rate(%) of Suriname in 2006 to that in 2007?
Keep it short and to the point. 1.05. What is the ratio of the Net enrolment rate(%) in United States in 2006 to that in 2007?
Offer a terse response. 0.99. What is the ratio of the Net enrolment rate(%) in South Asia in 2006 to that in 2008?
Offer a terse response. 0.98. What is the ratio of the Net enrolment rate(%) in Burundi in 2006 to that in 2008?
Make the answer very short. 0.81. What is the ratio of the Net enrolment rate(%) of South Asia in 2006 to that in 2009?
Your answer should be very brief. 0.97. What is the ratio of the Net enrolment rate(%) of Burundi in 2006 to that in 2009?
Make the answer very short. 0.83. What is the ratio of the Net enrolment rate(%) of Suriname in 2006 to that in 2009?
Provide a succinct answer. 0.98. What is the ratio of the Net enrolment rate(%) in South Asia in 2006 to that in 2013?
Keep it short and to the point. 0.97. What is the ratio of the Net enrolment rate(%) of Burundi in 2006 to that in 2013?
Your response must be concise. 0.78. What is the ratio of the Net enrolment rate(%) in Suriname in 2006 to that in 2013?
Ensure brevity in your answer.  1.11. What is the ratio of the Net enrolment rate(%) of United States in 2006 to that in 2013?
Keep it short and to the point. 1.03. What is the ratio of the Net enrolment rate(%) in Burundi in 2007 to that in 2008?
Keep it short and to the point. 0.89. What is the ratio of the Net enrolment rate(%) of Suriname in 2007 to that in 2008?
Provide a short and direct response. 0.95. What is the ratio of the Net enrolment rate(%) in United States in 2007 to that in 2008?
Your answer should be very brief. 1. What is the ratio of the Net enrolment rate(%) in South Asia in 2007 to that in 2009?
Offer a very short reply. 0.99. What is the ratio of the Net enrolment rate(%) in Burundi in 2007 to that in 2009?
Your answer should be very brief. 0.91. What is the ratio of the Net enrolment rate(%) in Suriname in 2007 to that in 2009?
Keep it short and to the point. 0.93. What is the ratio of the Net enrolment rate(%) of United States in 2007 to that in 2009?
Your response must be concise. 1.01. What is the ratio of the Net enrolment rate(%) in Burundi in 2007 to that in 2013?
Provide a succinct answer. 0.85. What is the ratio of the Net enrolment rate(%) in Suriname in 2007 to that in 2013?
Offer a terse response. 1.05. What is the ratio of the Net enrolment rate(%) of United States in 2007 to that in 2013?
Provide a succinct answer. 1.04. What is the ratio of the Net enrolment rate(%) of South Asia in 2008 to that in 2009?
Give a very brief answer. 0.99. What is the ratio of the Net enrolment rate(%) of Burundi in 2008 to that in 2009?
Provide a succinct answer. 1.02. What is the ratio of the Net enrolment rate(%) of Suriname in 2008 to that in 2009?
Ensure brevity in your answer.  0.98. What is the ratio of the Net enrolment rate(%) in United States in 2008 to that in 2009?
Provide a short and direct response. 1.02. What is the ratio of the Net enrolment rate(%) in Burundi in 2008 to that in 2013?
Provide a short and direct response. 0.96. What is the ratio of the Net enrolment rate(%) in Suriname in 2008 to that in 2013?
Your response must be concise. 1.1. What is the ratio of the Net enrolment rate(%) of United States in 2008 to that in 2013?
Make the answer very short. 1.04. What is the ratio of the Net enrolment rate(%) of Burundi in 2009 to that in 2013?
Your response must be concise. 0.94. What is the ratio of the Net enrolment rate(%) of Suriname in 2009 to that in 2013?
Give a very brief answer. 1.13. What is the ratio of the Net enrolment rate(%) of United States in 2009 to that in 2013?
Your answer should be compact. 1.03. What is the difference between the highest and the second highest Net enrolment rate(%) of South Asia?
Provide a short and direct response. 0.2. What is the difference between the highest and the second highest Net enrolment rate(%) of Burundi?
Provide a short and direct response. 3.94. What is the difference between the highest and the second highest Net enrolment rate(%) of Suriname?
Your answer should be very brief. 7.78. What is the difference between the highest and the second highest Net enrolment rate(%) of United States?
Provide a short and direct response. 0.35. What is the difference between the highest and the lowest Net enrolment rate(%) in South Asia?
Make the answer very short. 21.74. What is the difference between the highest and the lowest Net enrolment rate(%) in Burundi?
Make the answer very short. 48.08. What is the difference between the highest and the lowest Net enrolment rate(%) in Suriname?
Keep it short and to the point. 18.19. What is the difference between the highest and the lowest Net enrolment rate(%) in United States?
Provide a succinct answer. 3.78. 